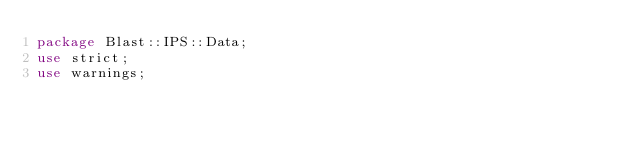Convert code to text. <code><loc_0><loc_0><loc_500><loc_500><_Perl_>package Blast::IPS::Data;
use strict;
use warnings;
</code> 